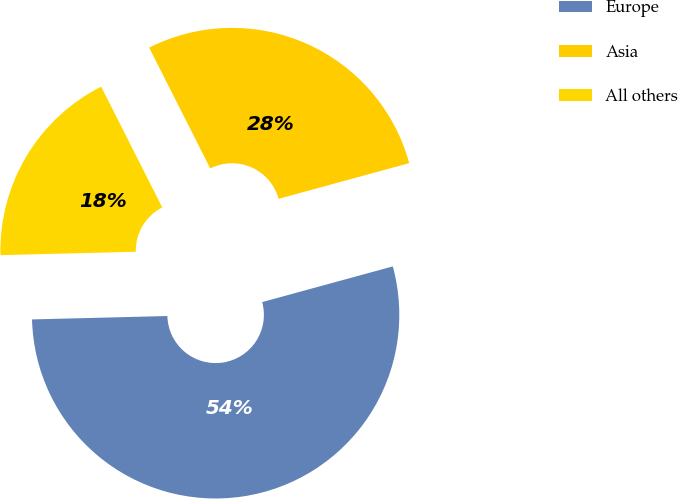Convert chart to OTSL. <chart><loc_0><loc_0><loc_500><loc_500><pie_chart><fcel>Europe<fcel>Asia<fcel>All others<nl><fcel>53.85%<fcel>28.21%<fcel>17.95%<nl></chart> 